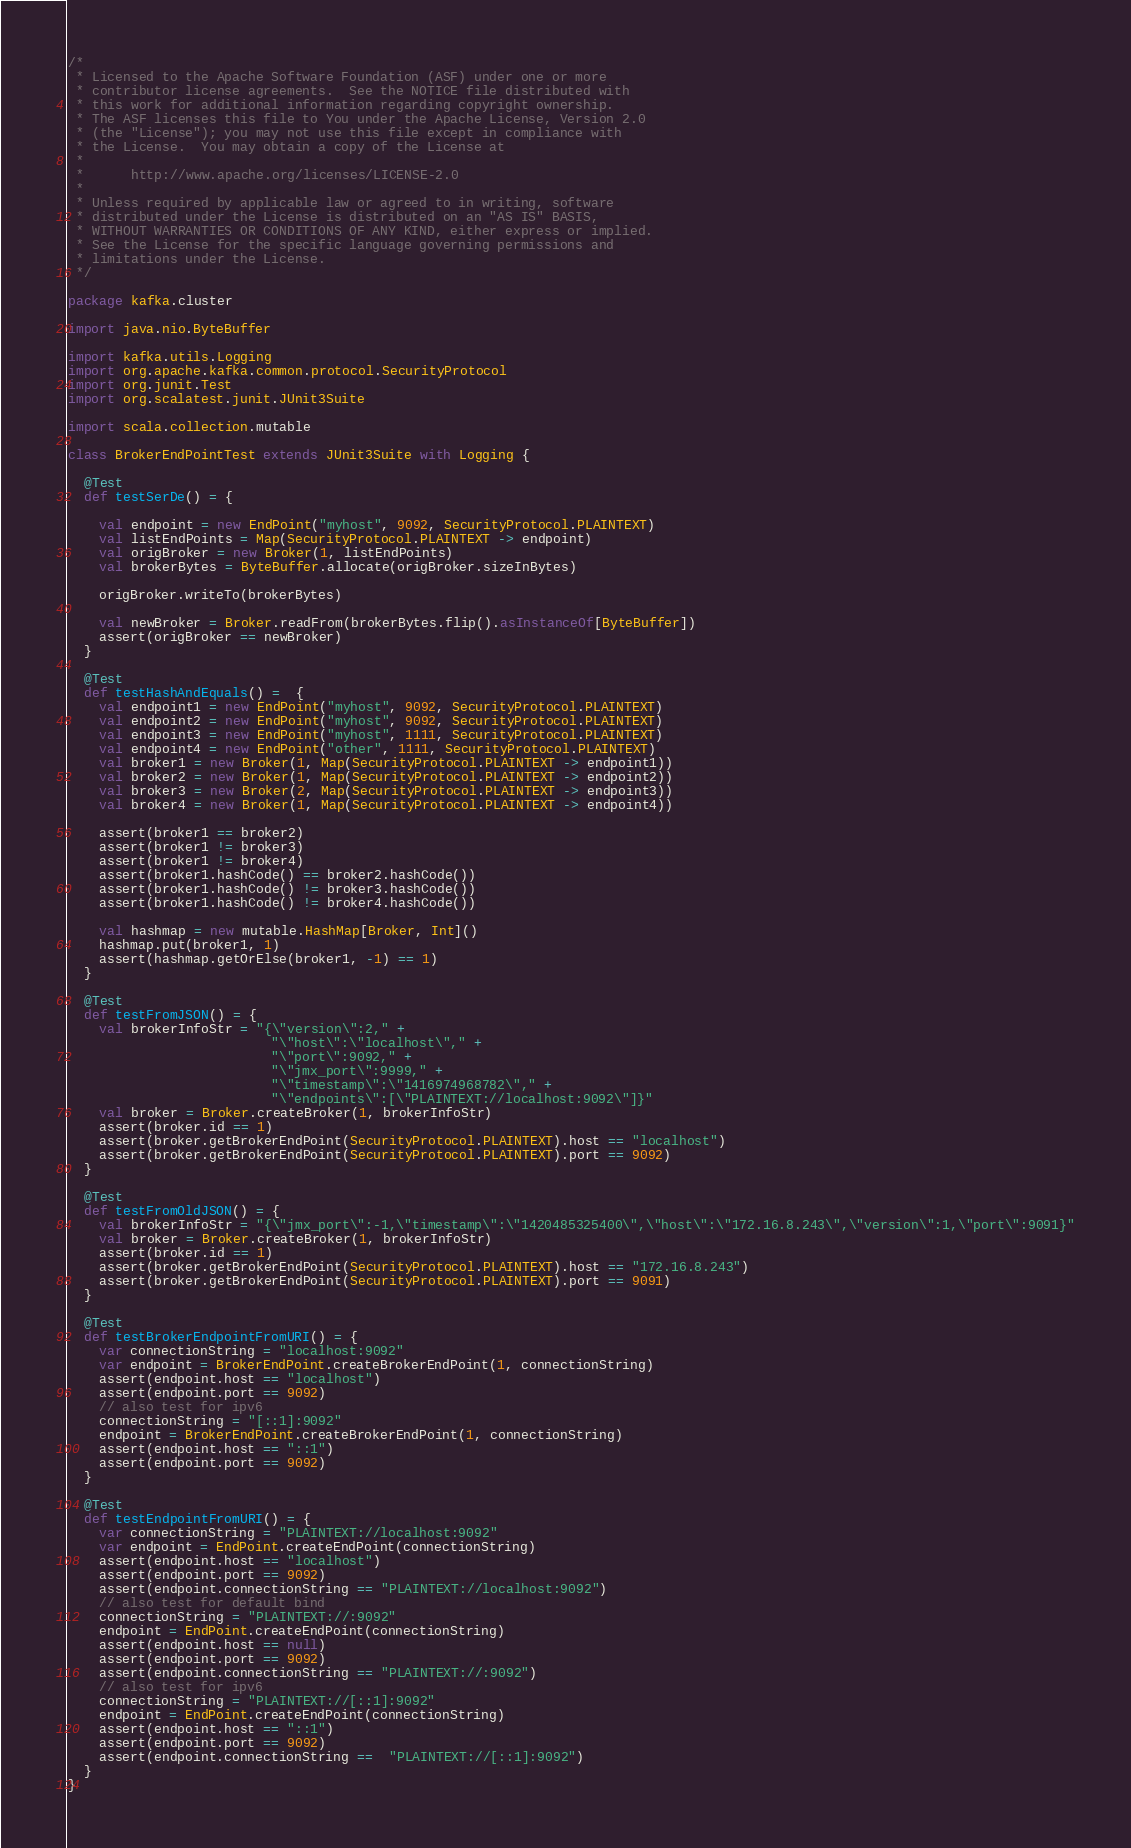<code> <loc_0><loc_0><loc_500><loc_500><_Scala_>/*
 * Licensed to the Apache Software Foundation (ASF) under one or more
 * contributor license agreements.  See the NOTICE file distributed with
 * this work for additional information regarding copyright ownership.
 * The ASF licenses this file to You under the Apache License, Version 2.0
 * (the "License"); you may not use this file except in compliance with
 * the License.  You may obtain a copy of the License at
 *
 *      http://www.apache.org/licenses/LICENSE-2.0
 *
 * Unless required by applicable law or agreed to in writing, software
 * distributed under the License is distributed on an "AS IS" BASIS,
 * WITHOUT WARRANTIES OR CONDITIONS OF ANY KIND, either express or implied.
 * See the License for the specific language governing permissions and
 * limitations under the License.
 */

package kafka.cluster

import java.nio.ByteBuffer

import kafka.utils.Logging
import org.apache.kafka.common.protocol.SecurityProtocol
import org.junit.Test
import org.scalatest.junit.JUnit3Suite

import scala.collection.mutable

class BrokerEndPointTest extends JUnit3Suite with Logging {

  @Test
  def testSerDe() = {

    val endpoint = new EndPoint("myhost", 9092, SecurityProtocol.PLAINTEXT)
    val listEndPoints = Map(SecurityProtocol.PLAINTEXT -> endpoint)
    val origBroker = new Broker(1, listEndPoints)
    val brokerBytes = ByteBuffer.allocate(origBroker.sizeInBytes)

    origBroker.writeTo(brokerBytes)

    val newBroker = Broker.readFrom(brokerBytes.flip().asInstanceOf[ByteBuffer])
    assert(origBroker == newBroker)
  }

  @Test
  def testHashAndEquals() =  {
    val endpoint1 = new EndPoint("myhost", 9092, SecurityProtocol.PLAINTEXT)
    val endpoint2 = new EndPoint("myhost", 9092, SecurityProtocol.PLAINTEXT)
    val endpoint3 = new EndPoint("myhost", 1111, SecurityProtocol.PLAINTEXT)
    val endpoint4 = new EndPoint("other", 1111, SecurityProtocol.PLAINTEXT)
    val broker1 = new Broker(1, Map(SecurityProtocol.PLAINTEXT -> endpoint1))
    val broker2 = new Broker(1, Map(SecurityProtocol.PLAINTEXT -> endpoint2))
    val broker3 = new Broker(2, Map(SecurityProtocol.PLAINTEXT -> endpoint3))
    val broker4 = new Broker(1, Map(SecurityProtocol.PLAINTEXT -> endpoint4))

    assert(broker1 == broker2)
    assert(broker1 != broker3)
    assert(broker1 != broker4)
    assert(broker1.hashCode() == broker2.hashCode())
    assert(broker1.hashCode() != broker3.hashCode())
    assert(broker1.hashCode() != broker4.hashCode())

    val hashmap = new mutable.HashMap[Broker, Int]()
    hashmap.put(broker1, 1)
    assert(hashmap.getOrElse(broker1, -1) == 1)
  }

  @Test
  def testFromJSON() = {
    val brokerInfoStr = "{\"version\":2," +
                          "\"host\":\"localhost\"," +
                          "\"port\":9092," +
                          "\"jmx_port\":9999," +
                          "\"timestamp\":\"1416974968782\"," +
                          "\"endpoints\":[\"PLAINTEXT://localhost:9092\"]}"
    val broker = Broker.createBroker(1, brokerInfoStr)
    assert(broker.id == 1)
    assert(broker.getBrokerEndPoint(SecurityProtocol.PLAINTEXT).host == "localhost")
    assert(broker.getBrokerEndPoint(SecurityProtocol.PLAINTEXT).port == 9092)
  }

  @Test
  def testFromOldJSON() = {
    val brokerInfoStr = "{\"jmx_port\":-1,\"timestamp\":\"1420485325400\",\"host\":\"172.16.8.243\",\"version\":1,\"port\":9091}"
    val broker = Broker.createBroker(1, brokerInfoStr)
    assert(broker.id == 1)
    assert(broker.getBrokerEndPoint(SecurityProtocol.PLAINTEXT).host == "172.16.8.243")
    assert(broker.getBrokerEndPoint(SecurityProtocol.PLAINTEXT).port == 9091)
  }

  @Test
  def testBrokerEndpointFromURI() = {
    var connectionString = "localhost:9092"
    var endpoint = BrokerEndPoint.createBrokerEndPoint(1, connectionString)
    assert(endpoint.host == "localhost")
    assert(endpoint.port == 9092)
    // also test for ipv6
    connectionString = "[::1]:9092"
    endpoint = BrokerEndPoint.createBrokerEndPoint(1, connectionString)
    assert(endpoint.host == "::1")
    assert(endpoint.port == 9092)
  }

  @Test
  def testEndpointFromURI() = {
    var connectionString = "PLAINTEXT://localhost:9092"
    var endpoint = EndPoint.createEndPoint(connectionString)
    assert(endpoint.host == "localhost")
    assert(endpoint.port == 9092)
    assert(endpoint.connectionString == "PLAINTEXT://localhost:9092")
    // also test for default bind
    connectionString = "PLAINTEXT://:9092"
    endpoint = EndPoint.createEndPoint(connectionString)
    assert(endpoint.host == null)
    assert(endpoint.port == 9092)
    assert(endpoint.connectionString == "PLAINTEXT://:9092")
    // also test for ipv6
    connectionString = "PLAINTEXT://[::1]:9092"
    endpoint = EndPoint.createEndPoint(connectionString)
    assert(endpoint.host == "::1")
    assert(endpoint.port == 9092)
    assert(endpoint.connectionString ==  "PLAINTEXT://[::1]:9092")
  }
}
</code> 